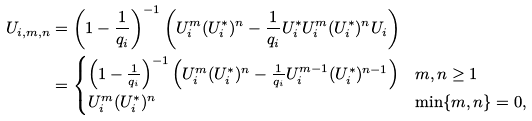Convert formula to latex. <formula><loc_0><loc_0><loc_500><loc_500>U _ { i , m , n } & = \left ( 1 - \frac { 1 } { q _ { i } } \right ) ^ { - 1 } \left ( U _ { i } ^ { m } ( U _ { i } ^ { * } ) ^ { n } - \frac { 1 } { q _ { i } } U _ { i } ^ { * } U _ { i } ^ { m } ( U _ { i } ^ { * } ) ^ { n } U _ { i } \right ) \\ & = \begin{cases} \left ( 1 - \frac { 1 } { q _ { i } } \right ) ^ { - 1 } \left ( U _ { i } ^ { m } ( U _ { i } ^ { * } ) ^ { n } - \frac { 1 } { q _ { i } } U _ { i } ^ { m - 1 } ( U _ { i } ^ { * } ) ^ { n - 1 } \right ) & m , n \geq 1 \\ U _ { i } ^ { m } ( U _ { i } ^ { * } ) ^ { n } & \min \{ m , n \} = 0 , \end{cases}</formula> 